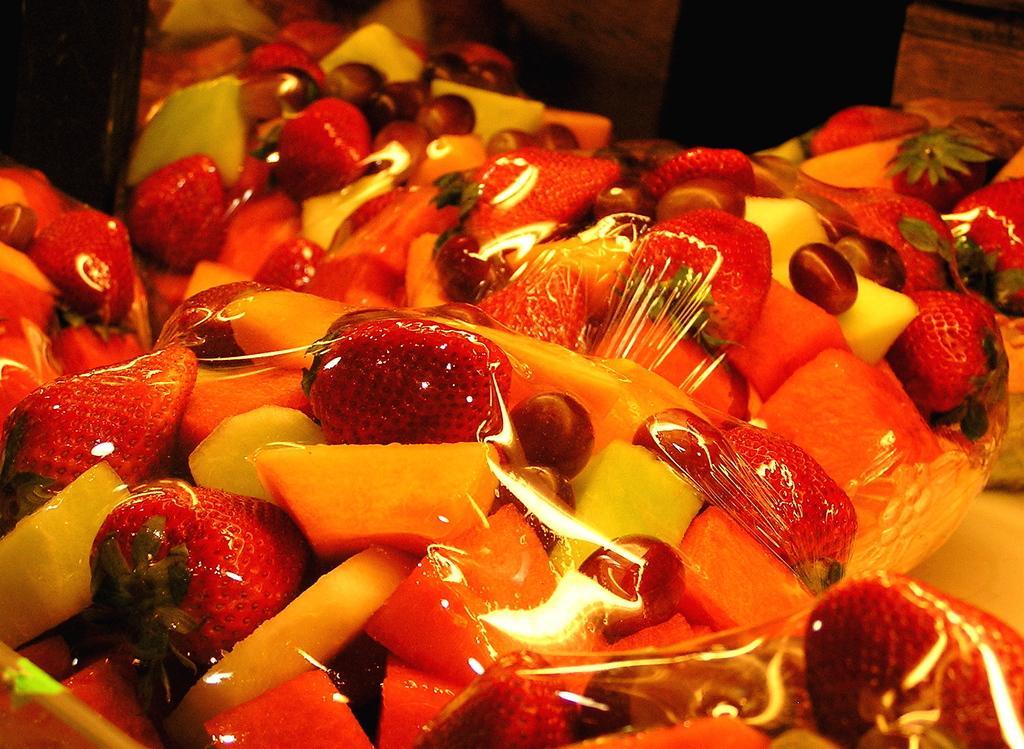Can you describe this image briefly? Here in this picture we can see fruits such as grapes, musk melon, papaya and strawberries are covered in a wrapper over there. 